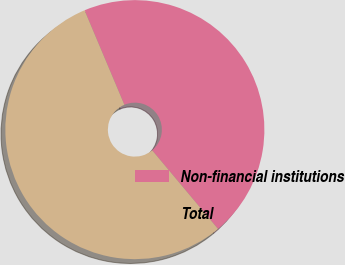Convert chart to OTSL. <chart><loc_0><loc_0><loc_500><loc_500><pie_chart><fcel>Non-financial institutions<fcel>Total<nl><fcel>45.25%<fcel>54.75%<nl></chart> 